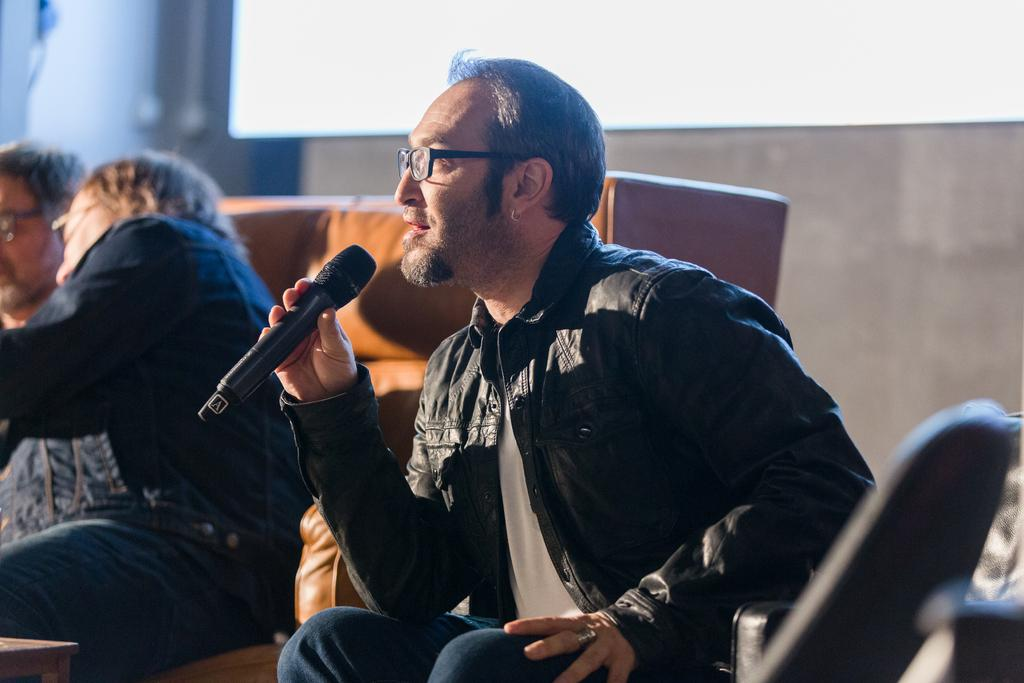What is the man in the image doing? The man is sitting and talking on a microphone. What is the man wearing in the image? The man is wearing a coat. How many people are sitting on the sofa in the image? There are two persons sitting on the sofa in the image. Can you tell me how many geese are sitting on the sofa in the image? There are no geese present in the image; it features a man sitting and talking on a microphone, as well as two persons sitting on a sofa. 